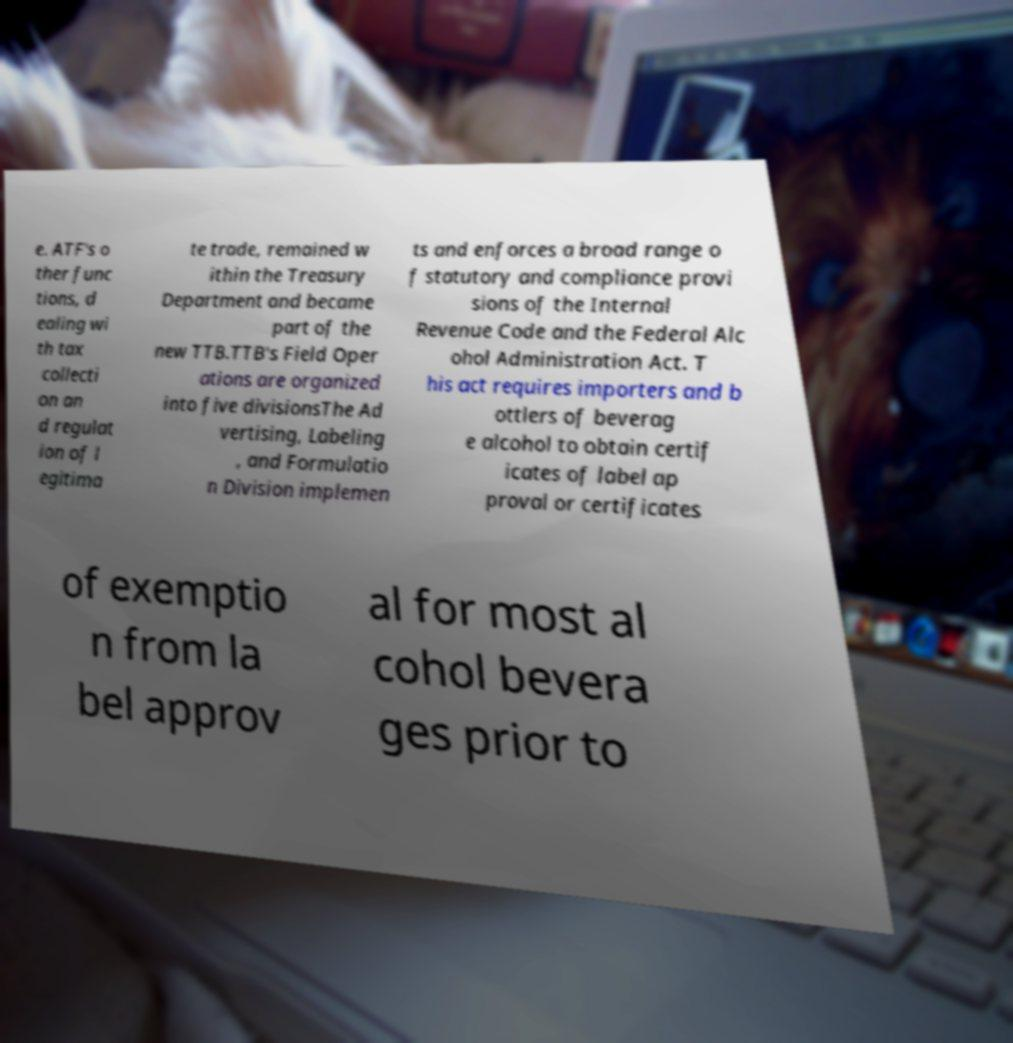There's text embedded in this image that I need extracted. Can you transcribe it verbatim? e. ATF's o ther func tions, d ealing wi th tax collecti on an d regulat ion of l egitima te trade, remained w ithin the Treasury Department and became part of the new TTB.TTB's Field Oper ations are organized into five divisionsThe Ad vertising, Labeling , and Formulatio n Division implemen ts and enforces a broad range o f statutory and compliance provi sions of the Internal Revenue Code and the Federal Alc ohol Administration Act. T his act requires importers and b ottlers of beverag e alcohol to obtain certif icates of label ap proval or certificates of exemptio n from la bel approv al for most al cohol bevera ges prior to 